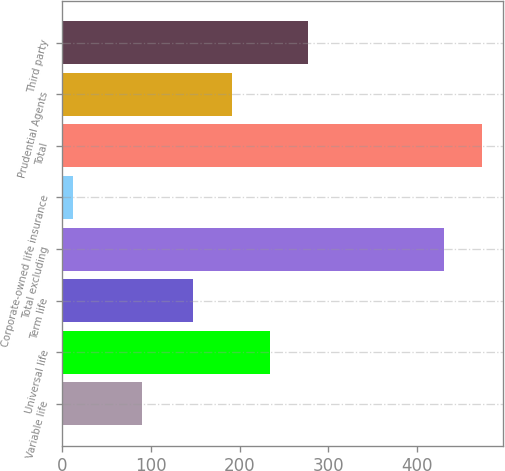Convert chart. <chart><loc_0><loc_0><loc_500><loc_500><bar_chart><fcel>Variable life<fcel>Universal life<fcel>Term life<fcel>Total excluding<fcel>Corporate-owned life insurance<fcel>Total<fcel>Prudential Agents<fcel>Third party<nl><fcel>90<fcel>234<fcel>148<fcel>430<fcel>12<fcel>473<fcel>191<fcel>277<nl></chart> 